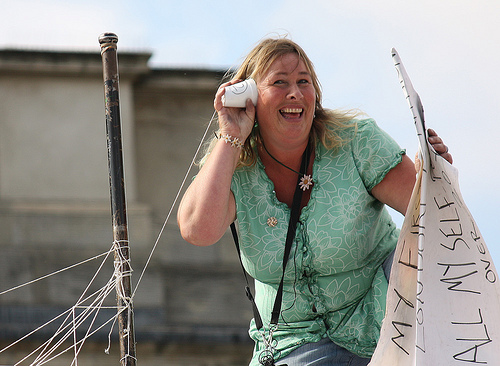<image>
Is there a breast on the woman? Yes. Looking at the image, I can see the breast is positioned on top of the woman, with the woman providing support. 